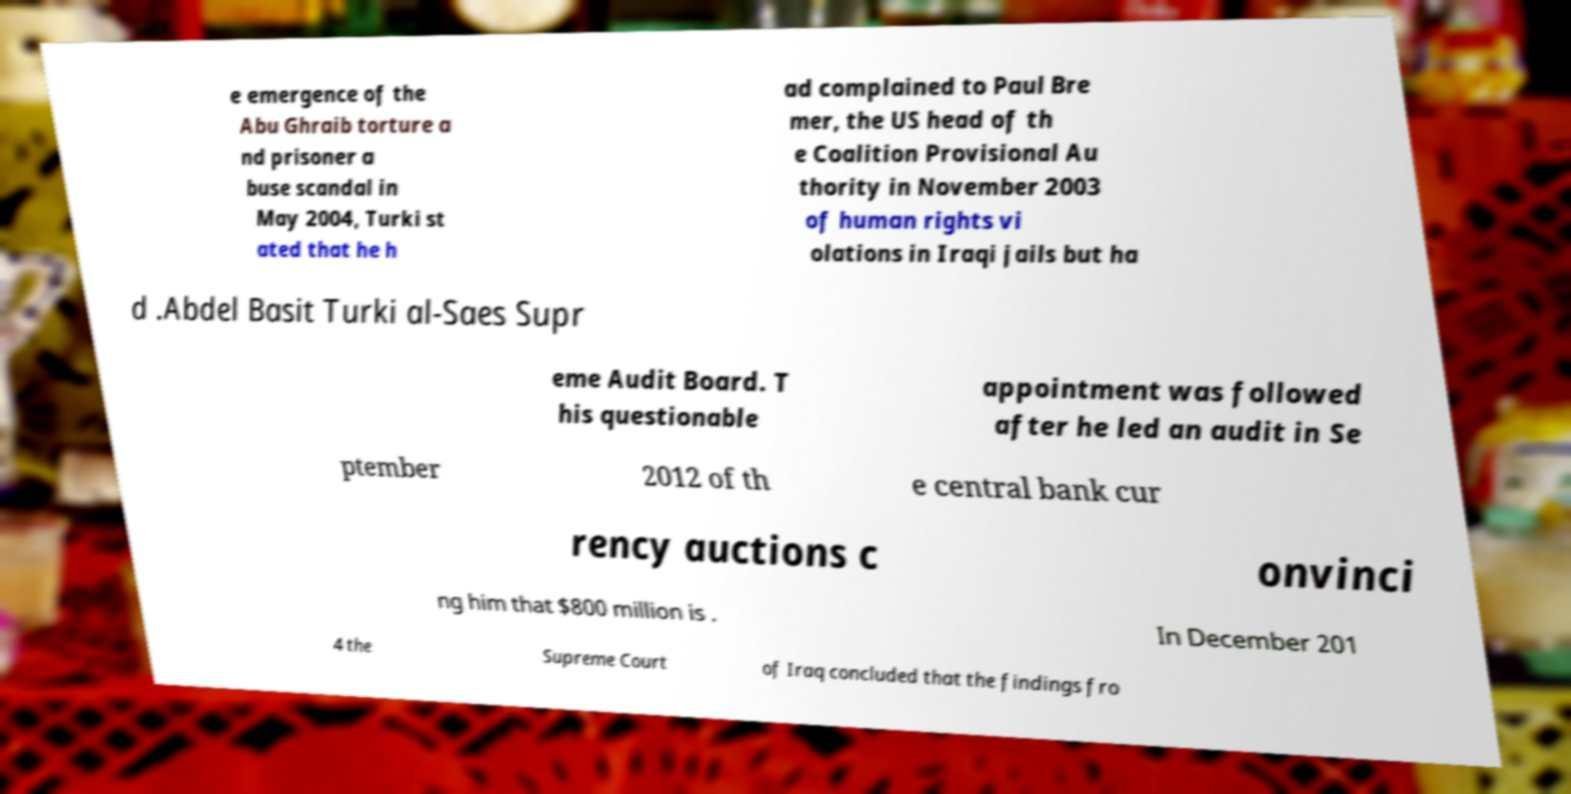Can you read and provide the text displayed in the image?This photo seems to have some interesting text. Can you extract and type it out for me? e emergence of the Abu Ghraib torture a nd prisoner a buse scandal in May 2004, Turki st ated that he h ad complained to Paul Bre mer, the US head of th e Coalition Provisional Au thority in November 2003 of human rights vi olations in Iraqi jails but ha d .Abdel Basit Turki al-Saes Supr eme Audit Board. T his questionable appointment was followed after he led an audit in Se ptember 2012 of th e central bank cur rency auctions c onvinci ng him that $800 million is . In December 201 4 the Supreme Court of Iraq concluded that the findings fro 